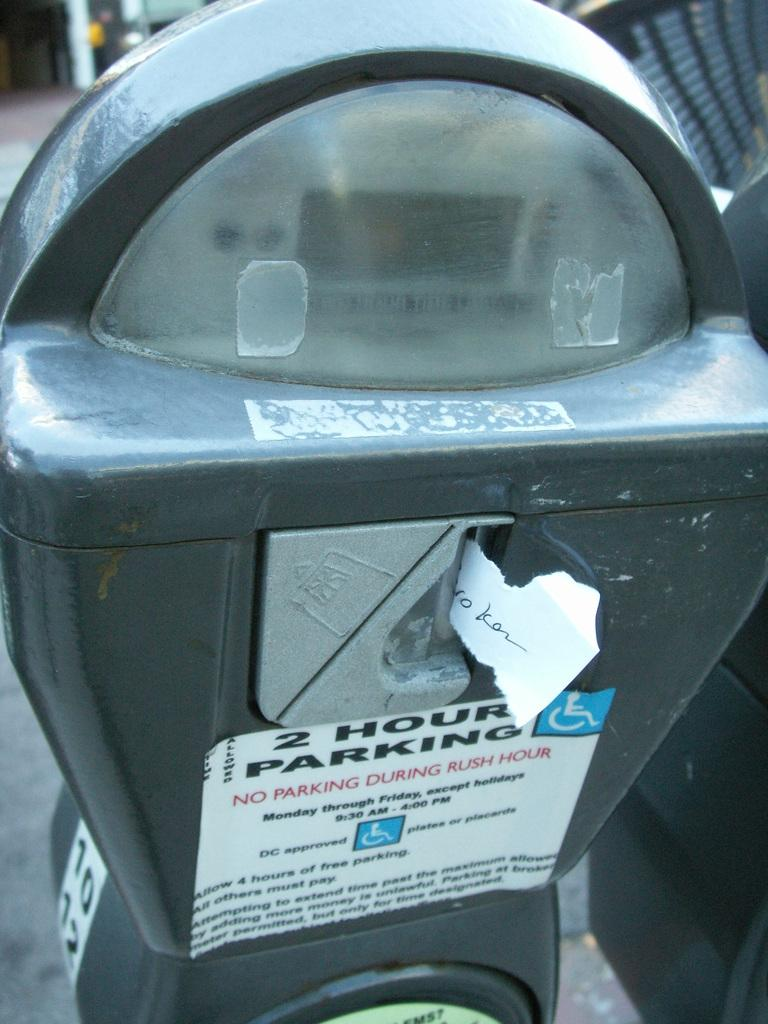<image>
Summarize the visual content of the image. 2 hour packing, but don't park during rush hour 